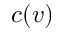Convert formula to latex. <formula><loc_0><loc_0><loc_500><loc_500>c ( v )</formula> 